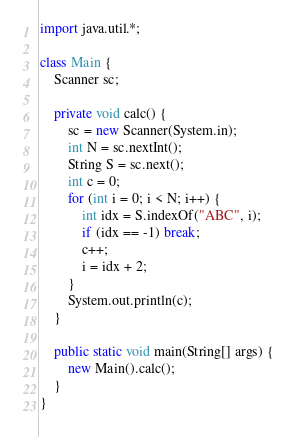<code> <loc_0><loc_0><loc_500><loc_500><_Java_>import java.util.*;

class Main {
	Scanner sc;
	
	private void calc() {
		sc = new Scanner(System.in);
		int N = sc.nextInt();
		String S = sc.next();
		int c = 0;
		for (int i = 0; i < N; i++) {
			int idx = S.indexOf("ABC", i);
			if (idx == -1) break;
			c++;
			i = idx + 2;
		}
		System.out.println(c);
	}

	public static void main(String[] args) {
		new Main().calc();
	}
}</code> 